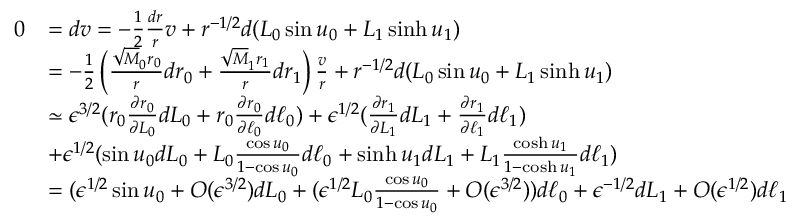Convert formula to latex. <formula><loc_0><loc_0><loc_500><loc_500>\begin{array} { r l } { 0 } & { = d v = - \frac { 1 } { 2 } \frac { d r } { r } v + r ^ { - 1 / 2 } d ( L _ { 0 } \sin u _ { 0 } + L _ { 1 } \sinh u _ { 1 } ) } \\ & { = - \frac { 1 } { 2 } \left ( \frac { \sqrt { M } _ { 0 } r _ { 0 } } { r } d r _ { 0 } + \frac { \sqrt { M } _ { 1 } r _ { 1 } } { r } d r _ { 1 } \right ) \frac { v } { r } + r ^ { - 1 / 2 } d ( L _ { 0 } \sin u _ { 0 } + L _ { 1 } \sinh u _ { 1 } ) } \\ & { \simeq \epsilon ^ { 3 / 2 } ( r _ { 0 } \frac { \partial r _ { 0 } } { \partial L _ { 0 } } d L _ { 0 } + r _ { 0 } \frac { \partial r _ { 0 } } { \partial \ell _ { 0 } } d \ell _ { 0 } ) + \epsilon ^ { 1 / 2 } ( \frac { \partial r _ { 1 } } { \partial L _ { 1 } } d L _ { 1 } + \frac { \partial r _ { 1 } } { \partial \ell _ { 1 } } d \ell _ { 1 } ) } \\ & { + \epsilon ^ { 1 / 2 } ( \sin u _ { 0 } d L _ { 0 } + L _ { 0 } \frac { \cos u _ { 0 } } { 1 - \cos u _ { 0 } } d \ell _ { 0 } + \sinh u _ { 1 } d L _ { 1 } + L _ { 1 } \frac { \cosh u _ { 1 } } { 1 - \cosh u _ { 1 } } d \ell _ { 1 } ) } \\ & { = ( \epsilon ^ { 1 / 2 } \sin u _ { 0 } + O ( \epsilon ^ { 3 / 2 } ) d L _ { 0 } + ( \epsilon ^ { 1 / 2 } L _ { 0 } \frac { \cos u _ { 0 } } { 1 - \cos u _ { 0 } } + O ( \epsilon ^ { 3 / 2 } ) ) d \ell _ { 0 } + \epsilon ^ { - 1 / 2 } d L _ { 1 } + O ( \epsilon ^ { 1 / 2 } ) d \ell _ { 1 } } \end{array}</formula> 